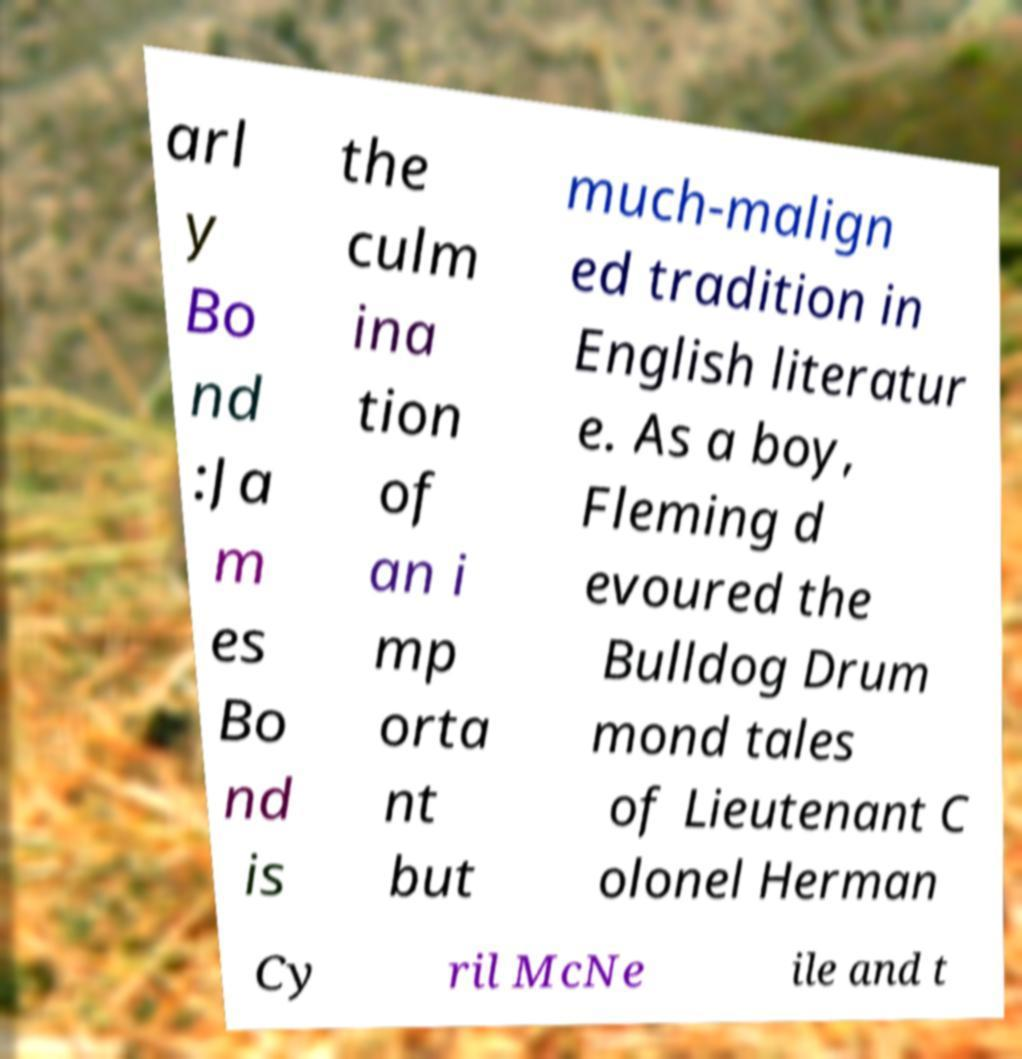What messages or text are displayed in this image? I need them in a readable, typed format. arl y Bo nd :Ja m es Bo nd is the culm ina tion of an i mp orta nt but much-malign ed tradition in English literatur e. As a boy, Fleming d evoured the Bulldog Drum mond tales of Lieutenant C olonel Herman Cy ril McNe ile and t 